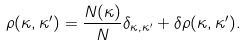<formula> <loc_0><loc_0><loc_500><loc_500>\rho ( \kappa , \kappa ^ { \prime } ) = \frac { N ( \kappa ) } { N } \delta _ { \kappa , \kappa ^ { \prime } } + \delta \rho ( \kappa , \kappa ^ { \prime } ) .</formula> 